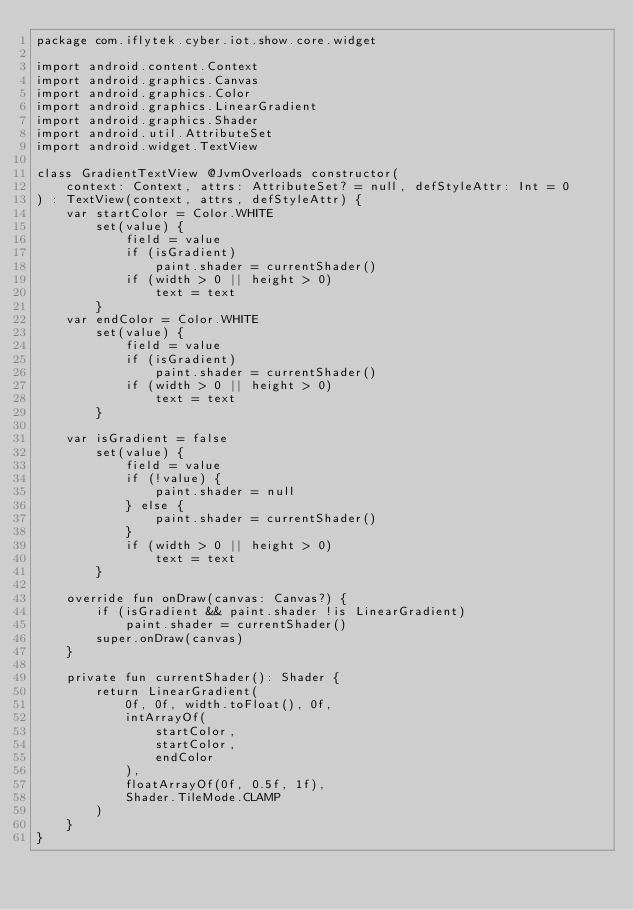<code> <loc_0><loc_0><loc_500><loc_500><_Kotlin_>package com.iflytek.cyber.iot.show.core.widget

import android.content.Context
import android.graphics.Canvas
import android.graphics.Color
import android.graphics.LinearGradient
import android.graphics.Shader
import android.util.AttributeSet
import android.widget.TextView

class GradientTextView @JvmOverloads constructor(
    context: Context, attrs: AttributeSet? = null, defStyleAttr: Int = 0
) : TextView(context, attrs, defStyleAttr) {
    var startColor = Color.WHITE
        set(value) {
            field = value
            if (isGradient)
                paint.shader = currentShader()
            if (width > 0 || height > 0)
                text = text
        }
    var endColor = Color.WHITE
        set(value) {
            field = value
            if (isGradient)
                paint.shader = currentShader()
            if (width > 0 || height > 0)
                text = text
        }

    var isGradient = false
        set(value) {
            field = value
            if (!value) {
                paint.shader = null
            } else {
                paint.shader = currentShader()
            }
            if (width > 0 || height > 0)
                text = text
        }

    override fun onDraw(canvas: Canvas?) {
        if (isGradient && paint.shader !is LinearGradient)
            paint.shader = currentShader()
        super.onDraw(canvas)
    }

    private fun currentShader(): Shader {
        return LinearGradient(
            0f, 0f, width.toFloat(), 0f,
            intArrayOf(
                startColor,
                startColor,
                endColor
            ),
            floatArrayOf(0f, 0.5f, 1f),
            Shader.TileMode.CLAMP
        )
    }
}</code> 